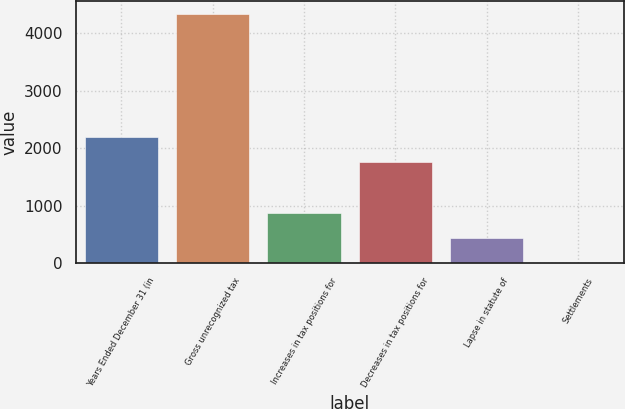Convert chart to OTSL. <chart><loc_0><loc_0><loc_500><loc_500><bar_chart><fcel>Years Ended December 31 (in<fcel>Gross unrecognized tax<fcel>Increases in tax positions for<fcel>Decreases in tax positions for<fcel>Lapse in statute of<fcel>Settlements<nl><fcel>2193.5<fcel>4340<fcel>878.6<fcel>1755.2<fcel>440.3<fcel>2<nl></chart> 